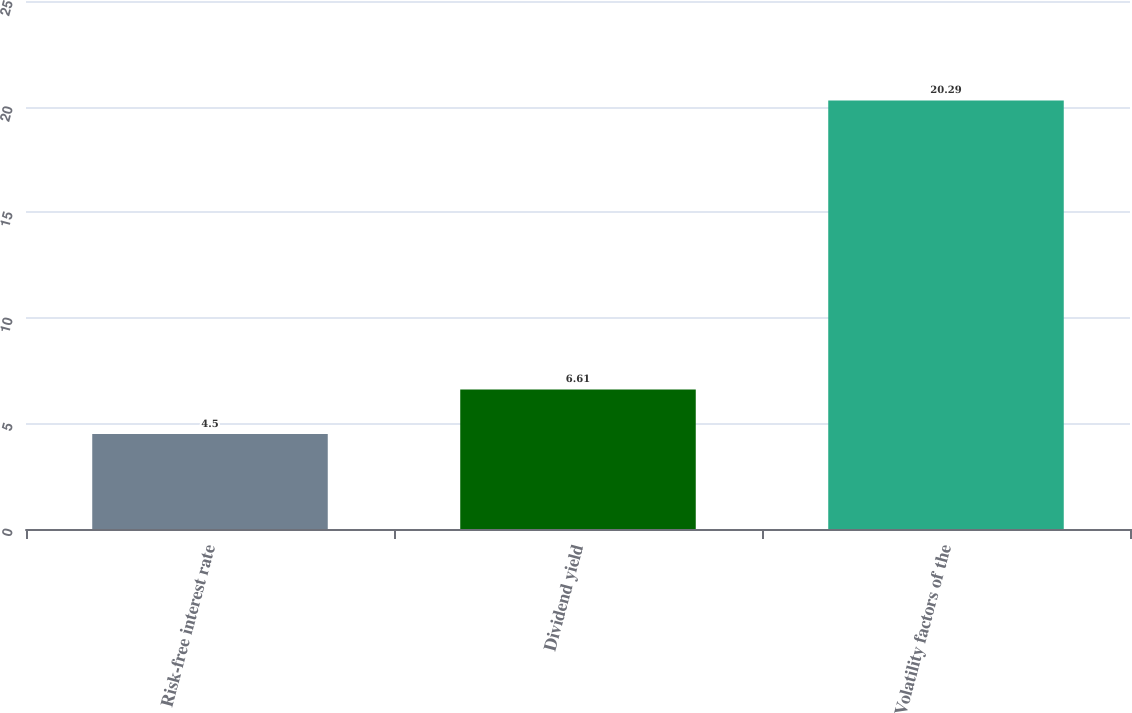Convert chart. <chart><loc_0><loc_0><loc_500><loc_500><bar_chart><fcel>Risk-free interest rate<fcel>Dividend yield<fcel>Volatility factors of the<nl><fcel>4.5<fcel>6.61<fcel>20.29<nl></chart> 